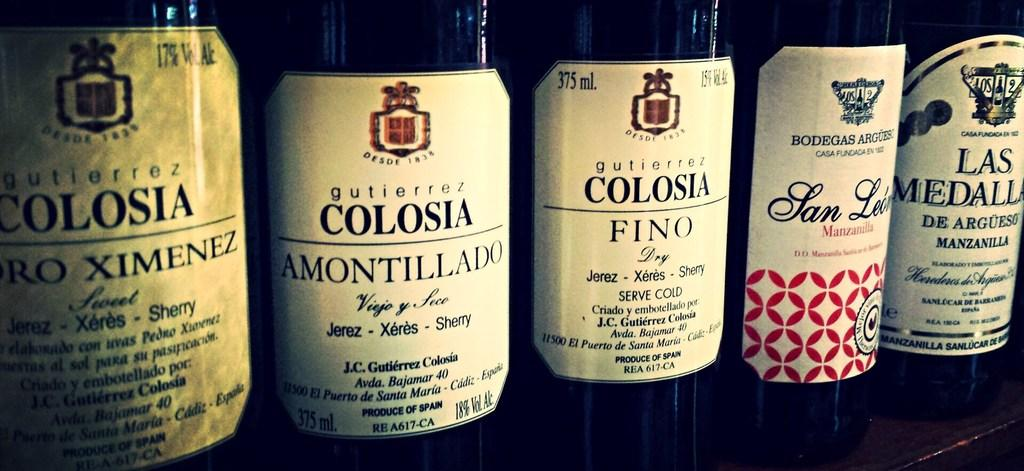<image>
Give a short and clear explanation of the subsequent image. Different Spanish wines, 3 from Colosia, are shown up close. 